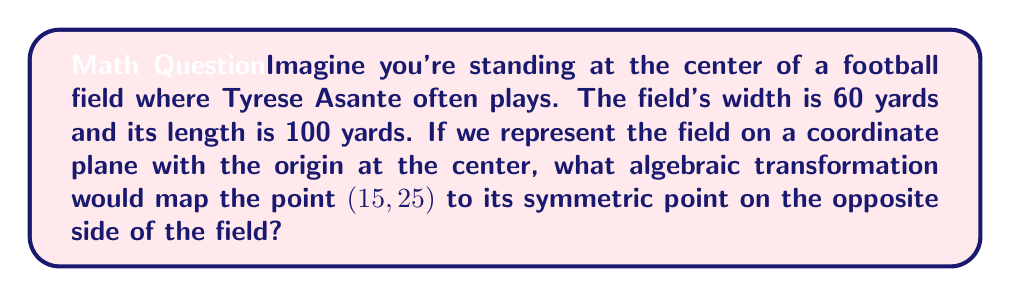Provide a solution to this math problem. Let's approach this step-by-step:

1) First, we need to understand the coordinate system. The origin $(0,0)$ is at the center of the field. The x-axis runs along the width, and the y-axis along the length.

2) The field dimensions in our coordinate system are:
   Width: $-30 \leq x \leq 30$
   Length: $-50 \leq y \leq 50$

3) The point $(15, 25)$ is in the first quadrant of our coordinate plane.

4) To find the symmetric point on the opposite side of the field, we need to reflect this point through the origin.

5) The general form of a reflection through the origin is:
   $$(x, y) \rightarrow (-x, -y)$$

6) Applying this transformation to our point:
   $(15, 25) \rightarrow (-15, -25)$

7) We can express this as a matrix transformation:
   $$\begin{pmatrix} -1 & 0 \\ 0 & -1 \end{pmatrix} \begin{pmatrix} x \\ y \end{pmatrix} = \begin{pmatrix} -x \\ -y \end{pmatrix}$$

8) This transformation is equivalent to a rotation by 180° around the origin, which can be represented as:
   $$R_{180°} = \begin{pmatrix} \cos 180° & -\sin 180° \\ \sin 180° & \cos 180° \end{pmatrix} = \begin{pmatrix} -1 & 0 \\ 0 & -1 \end{pmatrix}$$
Answer: $\begin{pmatrix} -1 & 0 \\ 0 & -1 \end{pmatrix} \begin{pmatrix} x \\ y \end{pmatrix}$ 